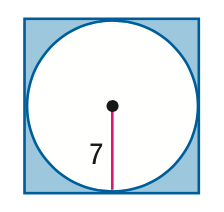Answer the mathemtical geometry problem and directly provide the correct option letter.
Question: Find the area of the shaded region. Assume that the polygon is regular unless otherwise stated. Round to the nearest tenth.
Choices: A: 42.1 B: 104.9 C: 153.9 D: 196 A 